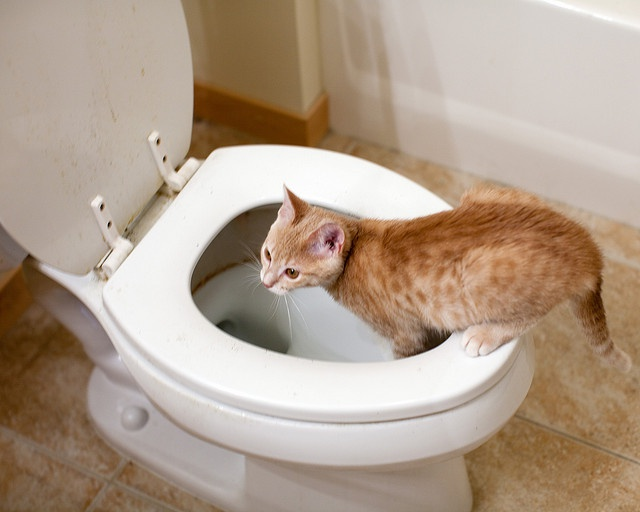Describe the objects in this image and their specific colors. I can see toilet in darkgray, white, and gray tones and cat in darkgray, gray, brown, and tan tones in this image. 